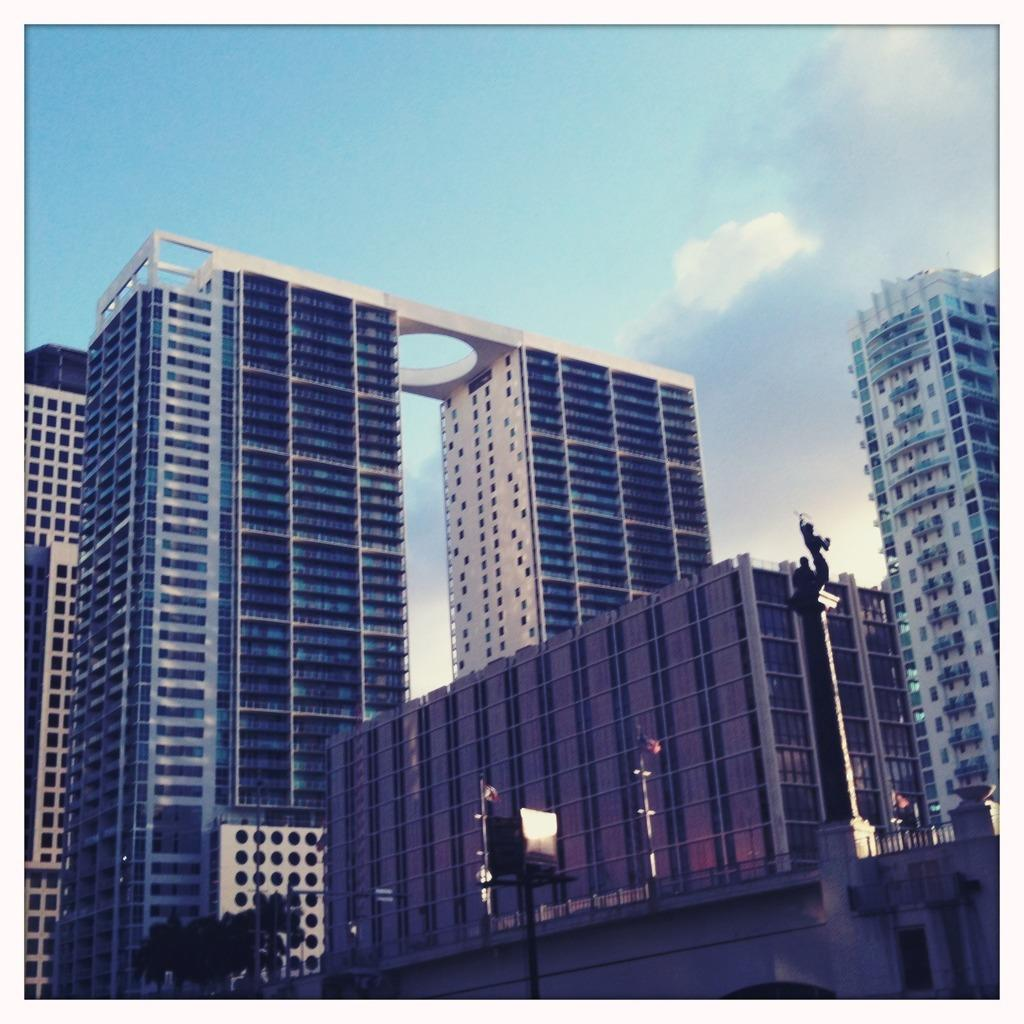What type of structures can be seen in the image? There are buildings in the image. What else can be seen in the image besides buildings? There are poles, a railing, trees, and a statue on a pole in the image. Can you describe the statue in the image? The statue is on a pole in the image. What is visible in the background of the image? The sky is visible in the background of the image. What type of dirt can be seen on the statue's head in the image? There is no dirt or head present on the statue in the image; it is a statue on a pole. What idea does the statue represent in the image? The image does not provide any information about the statue's meaning or representation. 